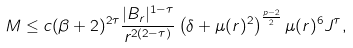Convert formula to latex. <formula><loc_0><loc_0><loc_500><loc_500>M \leq c ( \beta + 2 ) ^ { 2 \tau } \frac { | B _ { r } | ^ { 1 - \tau } } { r ^ { 2 ( 2 - \tau ) } } \left ( \delta + \mu ( r ) ^ { 2 } \right ) ^ { \frac { p - 2 } { 2 } } \mu ( r ) ^ { 6 } J ^ { \tau } ,</formula> 